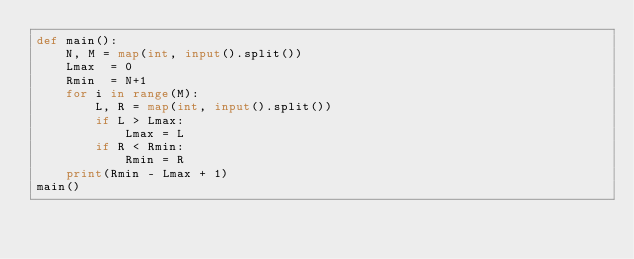Convert code to text. <code><loc_0><loc_0><loc_500><loc_500><_Python_>def main():
    N, M = map(int, input().split())
    Lmax  = 0
    Rmin  = N+1
    for i in range(M):
        L, R = map(int, input().split())
        if L > Lmax:
            Lmax = L
        if R < Rmin:
            Rmin = R
    print(Rmin - Lmax + 1)
main()</code> 